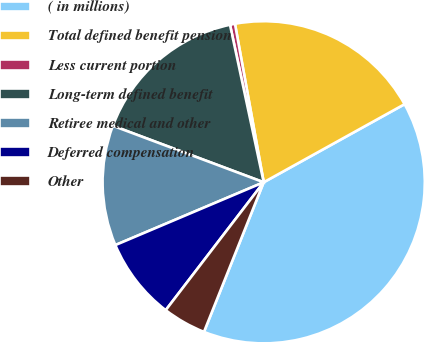Convert chart. <chart><loc_0><loc_0><loc_500><loc_500><pie_chart><fcel>( in millions)<fcel>Total defined benefit pension<fcel>Less current portion<fcel>Long-term defined benefit<fcel>Retiree medical and other<fcel>Deferred compensation<fcel>Other<nl><fcel>39.1%<fcel>19.8%<fcel>0.5%<fcel>15.94%<fcel>12.08%<fcel>8.22%<fcel>4.36%<nl></chart> 